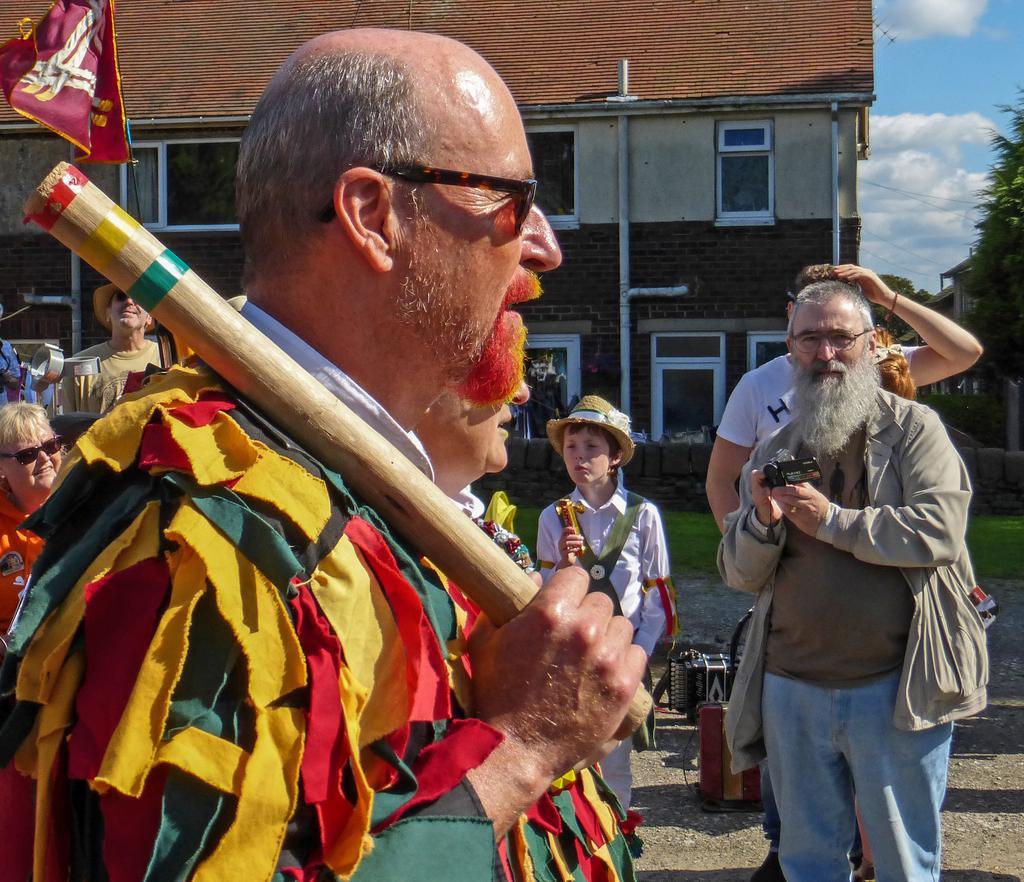Describe this image in one or two sentences. In this image, we can see a group of people. Here a person is holding a stick. On the right side of the image, a person is holding a camera and boy is holding some object. Background we can see building, brick wall, glass windows, pipes, flag, trees, few houses, grass and cloudy sky. 